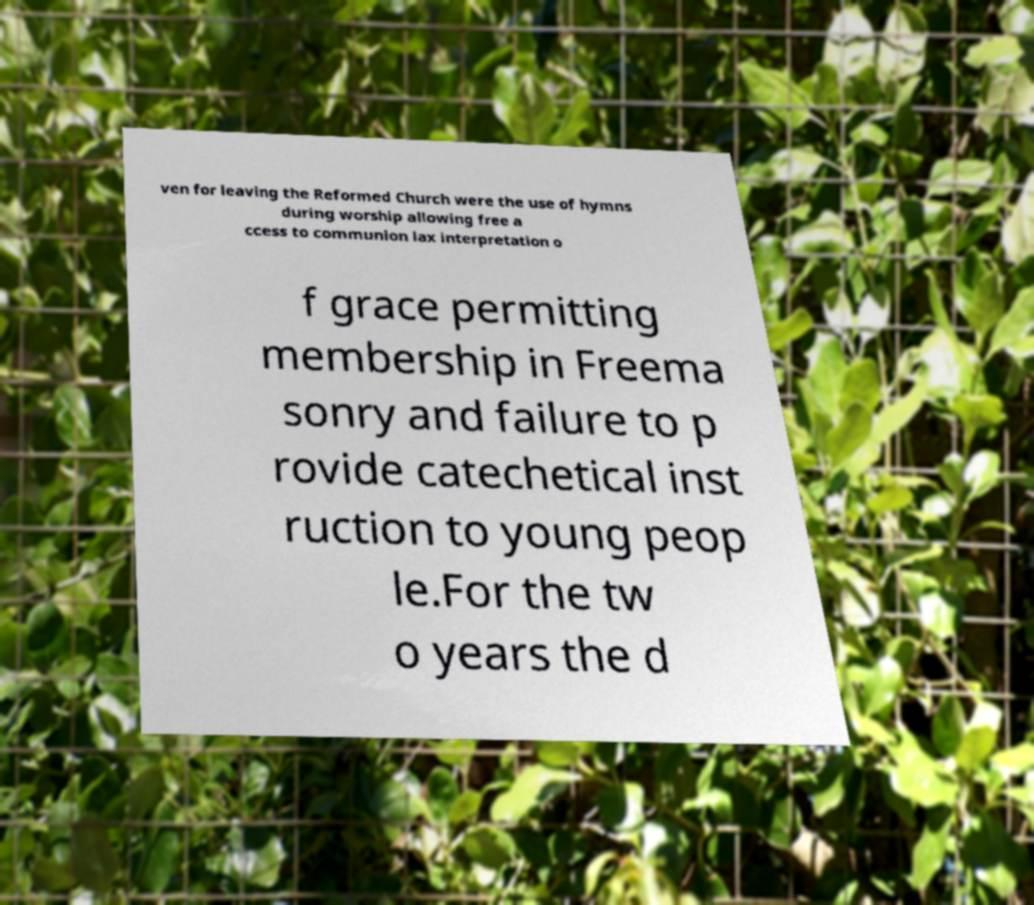I need the written content from this picture converted into text. Can you do that? ven for leaving the Reformed Church were the use of hymns during worship allowing free a ccess to communion lax interpretation o f grace permitting membership in Freema sonry and failure to p rovide catechetical inst ruction to young peop le.For the tw o years the d 